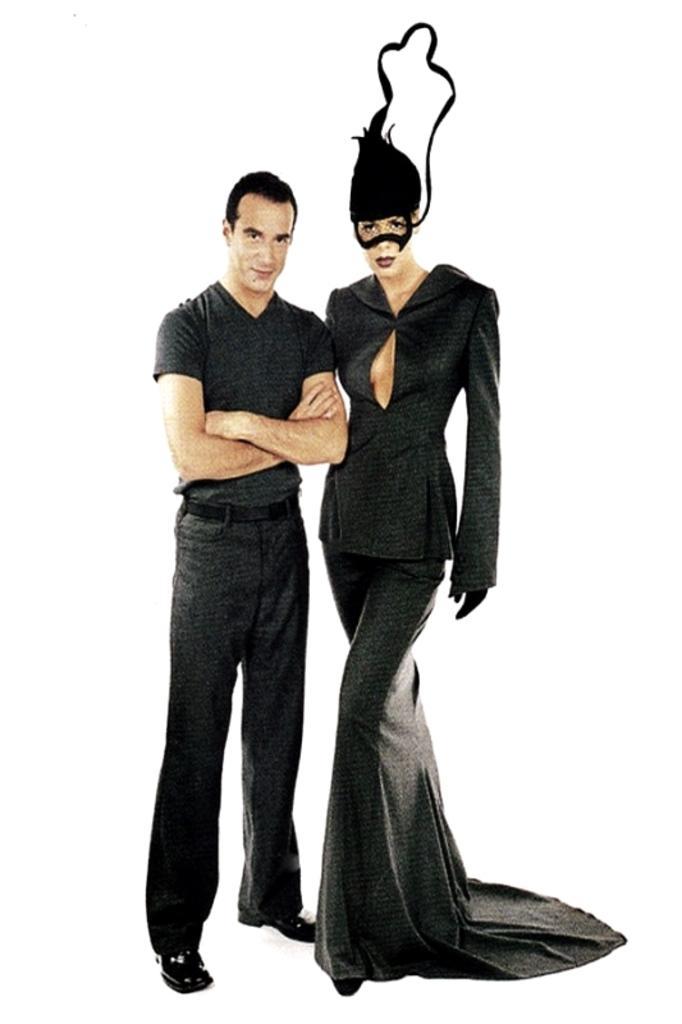Describe this image in one or two sentences. In this image I can see two persons and they are wearing black color dresses and I can see the white color background. 